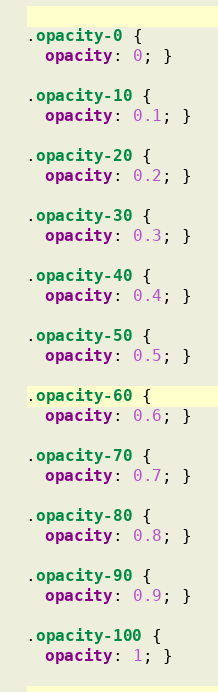<code> <loc_0><loc_0><loc_500><loc_500><_CSS_>.opacity-0 {
  opacity: 0; }

.opacity-10 {
  opacity: 0.1; }

.opacity-20 {
  opacity: 0.2; }

.opacity-30 {
  opacity: 0.3; }

.opacity-40 {
  opacity: 0.4; }

.opacity-50 {
  opacity: 0.5; }

.opacity-60 {
  opacity: 0.6; }

.opacity-70 {
  opacity: 0.7; }

.opacity-80 {
  opacity: 0.8; }

.opacity-90 {
  opacity: 0.9; }

.opacity-100 {
  opacity: 1; }
</code> 